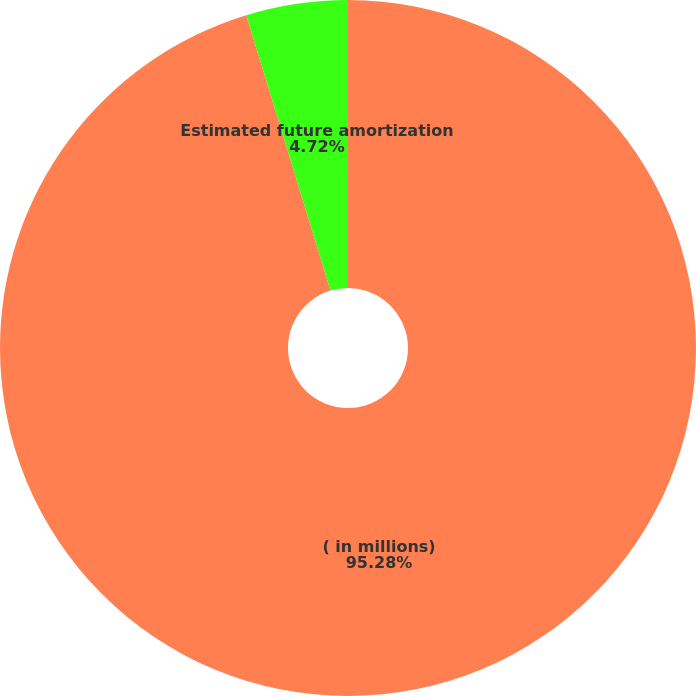Convert chart to OTSL. <chart><loc_0><loc_0><loc_500><loc_500><pie_chart><fcel>( in millions)<fcel>Estimated future amortization<nl><fcel>95.28%<fcel>4.72%<nl></chart> 